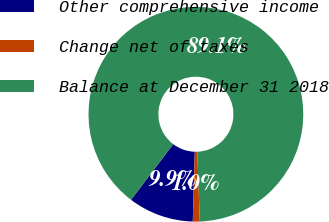Convert chart. <chart><loc_0><loc_0><loc_500><loc_500><pie_chart><fcel>Other comprehensive income<fcel>Change net of taxes<fcel>Balance at December 31 2018<nl><fcel>9.86%<fcel>1.05%<fcel>89.09%<nl></chart> 